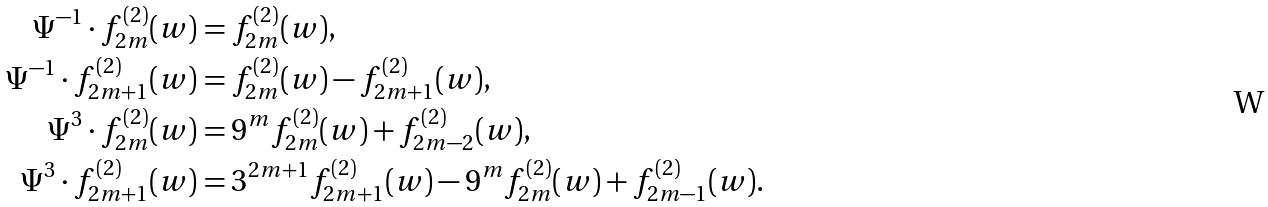Convert formula to latex. <formula><loc_0><loc_0><loc_500><loc_500>\Psi ^ { - 1 } \cdot f _ { 2 m } ^ { ( 2 ) } ( w ) & = f _ { 2 m } ^ { ( 2 ) } ( w ) , \\ \Psi ^ { - 1 } \cdot f _ { 2 m + 1 } ^ { ( 2 ) } ( w ) & = f _ { 2 m } ^ { ( 2 ) } ( w ) - f _ { 2 m + 1 } ^ { ( 2 ) } ( w ) , \\ \Psi ^ { 3 } \cdot f _ { 2 m } ^ { ( 2 ) } ( w ) & = 9 ^ { m } f _ { 2 m } ^ { ( 2 ) } ( w ) + f _ { 2 m - 2 } ^ { ( 2 ) } ( w ) , \\ \Psi ^ { 3 } \cdot f _ { 2 m + 1 } ^ { ( 2 ) } ( w ) & = 3 ^ { 2 m + 1 } f _ { 2 m + 1 } ^ { ( 2 ) } ( w ) - 9 ^ { m } f _ { 2 m } ^ { ( 2 ) } ( w ) + f _ { 2 m - 1 } ^ { ( 2 ) } ( w ) .</formula> 